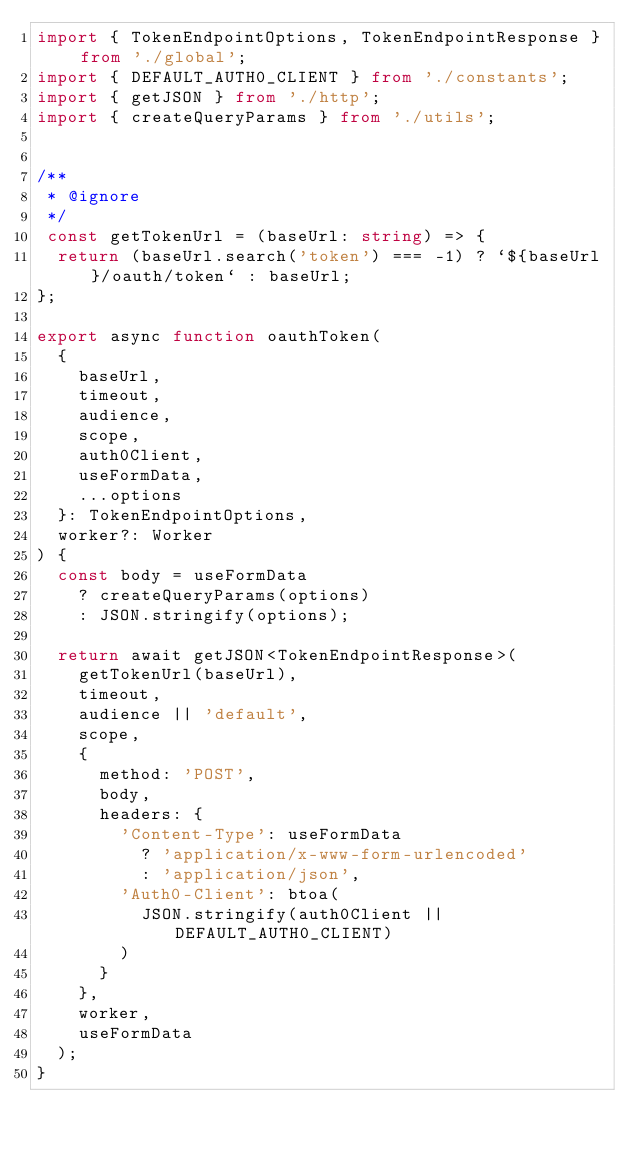Convert code to text. <code><loc_0><loc_0><loc_500><loc_500><_TypeScript_>import { TokenEndpointOptions, TokenEndpointResponse } from './global';
import { DEFAULT_AUTH0_CLIENT } from './constants';
import { getJSON } from './http';
import { createQueryParams } from './utils';


/**
 * @ignore
 */
 const getTokenUrl = (baseUrl: string) => {
  return (baseUrl.search('token') === -1) ? `${baseUrl}/oauth/token` : baseUrl;
};

export async function oauthToken(
  {
    baseUrl,
    timeout,
    audience,
    scope,
    auth0Client,
    useFormData,
    ...options
  }: TokenEndpointOptions,
  worker?: Worker
) {
  const body = useFormData
    ? createQueryParams(options)
    : JSON.stringify(options);

  return await getJSON<TokenEndpointResponse>(
    getTokenUrl(baseUrl),
    timeout,
    audience || 'default',
    scope,
    {
      method: 'POST',
      body,
      headers: {
        'Content-Type': useFormData
          ? 'application/x-www-form-urlencoded'
          : 'application/json',
        'Auth0-Client': btoa(
          JSON.stringify(auth0Client || DEFAULT_AUTH0_CLIENT)
        )
      }
    },
    worker,
    useFormData
  );
}
</code> 